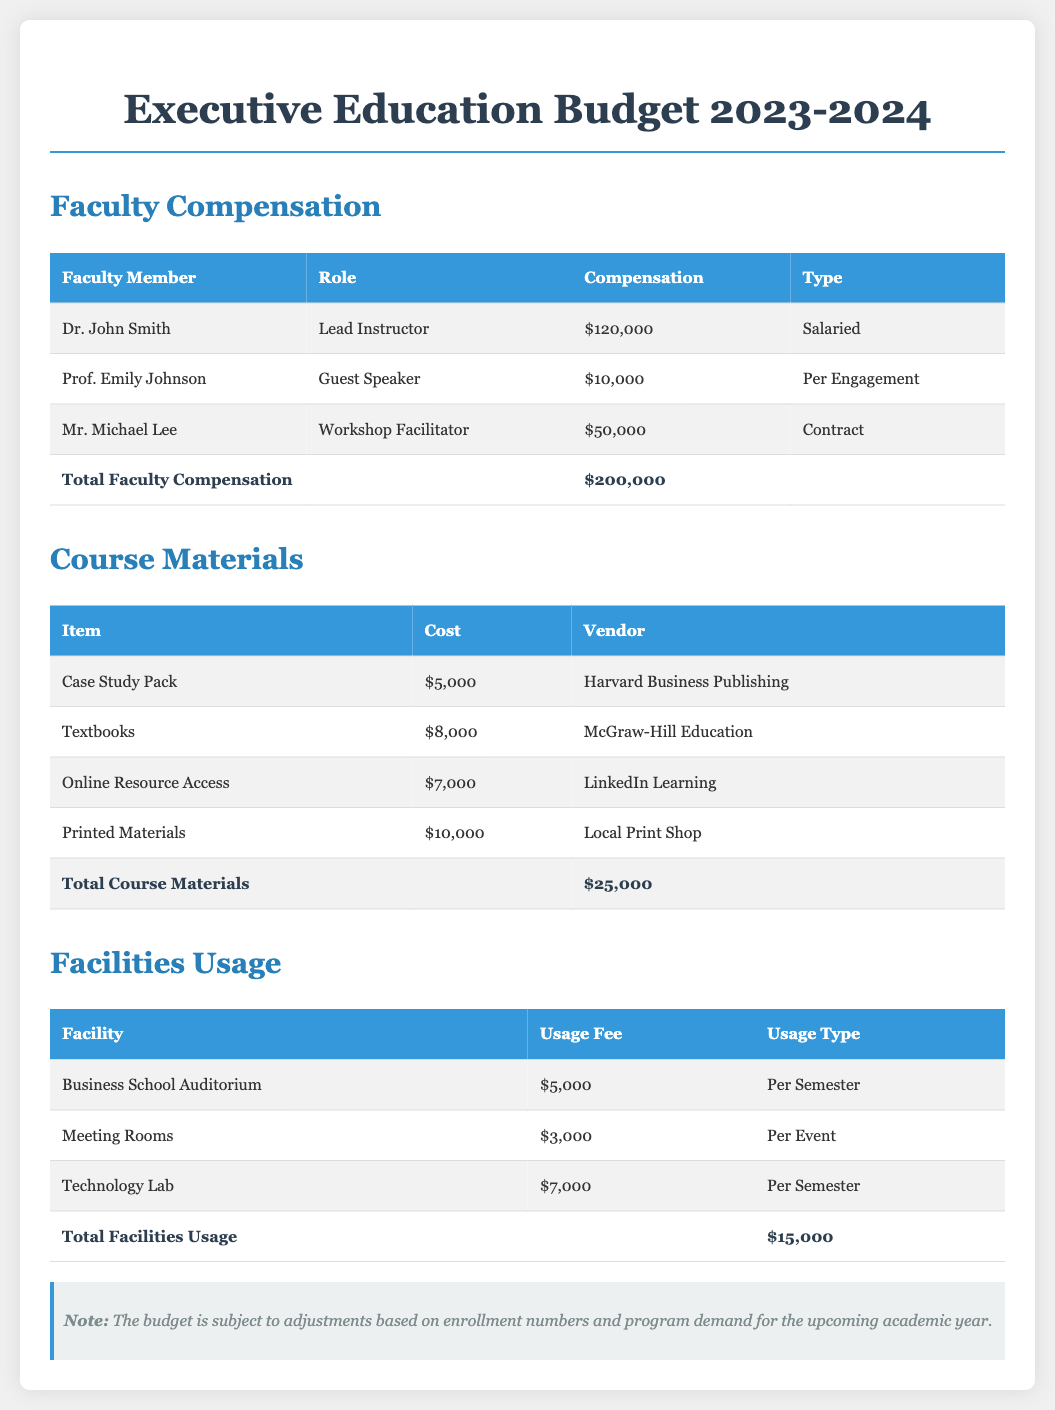What is the total faculty compensation? The total faculty compensation is the sum of all individual compensations listed, which is $120,000 + $10,000 + $50,000 = $200,000.
Answer: $200,000 Who is the lead instructor? The document lists Dr. John Smith as the lead instructor for the Executive Education program.
Answer: Dr. John Smith What is the cost of the printed materials? The cost of printed materials is explicitly stated in the table under Course Materials, amounting to $10,000.
Answer: $10,000 What is the total cost of course materials? The total cost of course materials is the sum of all items listed, equating to $5,000 + $8,000 + $7,000 + $10,000 = $25,000.
Answer: $25,000 How much does the Business School Auditorium cost per semester? The document specifically mentions that the Business School Auditorium has a usage fee of $5,000 per semester.
Answer: $5,000 What is the purpose of this budget document? The purpose of the document is to outline the budget for the Executive Education program for the academic year 2023-2024.
Answer: Outline budget Who is the vendor for textbooks? The document states McGraw-Hill Education as the vendor for the textbooks listed under Course Materials.
Answer: McGraw-Hill Education What is the total facilities usage cost? The total facilities usage cost is calculated as $5,000 + $3,000 + $7,000 = $15,000, as seen in the Facilities Usage table.
Answer: $15,000 What type of document is this? This document is categorized as a budget specifically for the Executive Education program for the academic year 2023-2024.
Answer: Budget document 